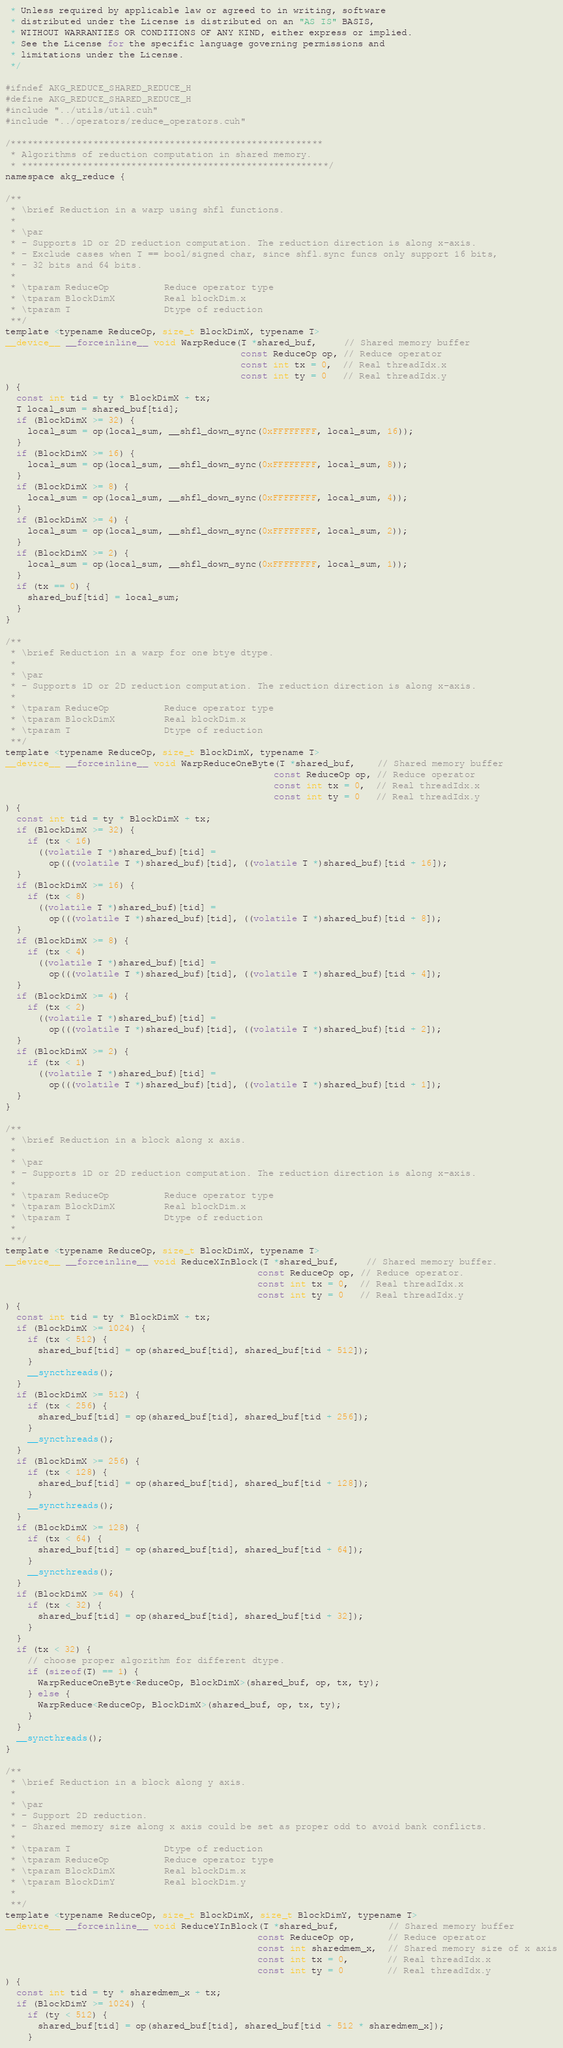Convert code to text. <code><loc_0><loc_0><loc_500><loc_500><_Cuda_> * Unless required by applicable law or agreed to in writing, software
 * distributed under the License is distributed on an "AS IS" BASIS,
 * WITHOUT WARRANTIES OR CONDITIONS OF ANY KIND, either express or implied.
 * See the License for the specific language governing permissions and
 * limitations under the License.
 */

#ifndef AKG_REDUCE_SHARED_REDUCE_H
#define AKG_REDUCE_SHARED_REDUCE_H
#include "../utils/util.cuh"
#include "../operators/reduce_operators.cuh"

/*********************************************************
 * Algorithms of reduction computation in shared memory.
 * ********************************************************/
namespace akg_reduce {

/**
 * \brief Reduction in a warp using shfl functions.
 *
 * \par
 * - Supports 1D or 2D reduction computation. The reduction direction is along x-axis.
 * - Exclude cases when T == bool/signed char, since shfl.sync funcs only support 16 bits,
 * - 32 bits and 64 bits.
 *
 * \tparam ReduceOp          Reduce operator type
 * \tparam BlockDimX         Real blockDim.x
 * \tparam T                 Dtype of reduction
 **/
template <typename ReduceOp, size_t BlockDimX, typename T>
__device__ __forceinline__ void WarpReduce(T *shared_buf,     // Shared memory buffer
                                           const ReduceOp op, // Reduce operator
                                           const int tx = 0,  // Real threadIdx.x
                                           const int ty = 0   // Real threadIdx.y
) {
  const int tid = ty * BlockDimX + tx;
  T local_sum = shared_buf[tid];
  if (BlockDimX >= 32) {
    local_sum = op(local_sum, __shfl_down_sync(0xFFFFFFFF, local_sum, 16));
  }
  if (BlockDimX >= 16) {
    local_sum = op(local_sum, __shfl_down_sync(0xFFFFFFFF, local_sum, 8));
  }
  if (BlockDimX >= 8) {
    local_sum = op(local_sum, __shfl_down_sync(0xFFFFFFFF, local_sum, 4));
  }
  if (BlockDimX >= 4) {
    local_sum = op(local_sum, __shfl_down_sync(0xFFFFFFFF, local_sum, 2));
  }
  if (BlockDimX >= 2) {
    local_sum = op(local_sum, __shfl_down_sync(0xFFFFFFFF, local_sum, 1));
  }
  if (tx == 0) {
    shared_buf[tid] = local_sum;
  }
}

/**
 * \brief Reduction in a warp for one btye dtype.
 *
 * \par
 * - Supports 1D or 2D reduction computation. The reduction direction is along x-axis.
 *
 * \tparam ReduceOp          Reduce operator type
 * \tparam BlockDimX         Real blockDim.x
 * \tparam T                 Dtype of reduction
 **/
template <typename ReduceOp, size_t BlockDimX, typename T>
__device__ __forceinline__ void WarpReduceOneByte(T *shared_buf,    // Shared memory buffer
                                                 const ReduceOp op, // Reduce operator
                                                 const int tx = 0,  // Real threadIdx.x
                                                 const int ty = 0   // Real threadIdx.y
) {
  const int tid = ty * BlockDimX + tx;
  if (BlockDimX >= 32) {
    if (tx < 16)
      ((volatile T *)shared_buf)[tid] =
        op(((volatile T *)shared_buf)[tid], ((volatile T *)shared_buf)[tid + 16]);
  }
  if (BlockDimX >= 16) {
    if (tx < 8)
      ((volatile T *)shared_buf)[tid] =
        op(((volatile T *)shared_buf)[tid], ((volatile T *)shared_buf)[tid + 8]);
  }
  if (BlockDimX >= 8) {
    if (tx < 4)
      ((volatile T *)shared_buf)[tid] =
        op(((volatile T *)shared_buf)[tid], ((volatile T *)shared_buf)[tid + 4]);
  }
  if (BlockDimX >= 4) {
    if (tx < 2)
      ((volatile T *)shared_buf)[tid] =
        op(((volatile T *)shared_buf)[tid], ((volatile T *)shared_buf)[tid + 2]);
  }
  if (BlockDimX >= 2) {
    if (tx < 1)
      ((volatile T *)shared_buf)[tid] =
        op(((volatile T *)shared_buf)[tid], ((volatile T *)shared_buf)[tid + 1]);
  }
}

/**
 * \brief Reduction in a block along x axis.
 *
 * \par
 * - Supports 1D or 2D reduction computation. The reduction direction is along x-axis.
 *
 * \tparam ReduceOp          Reduce operator type
 * \tparam BlockDimX         Real blockDim.x
 * \tparam T                 Dtype of reduction
 *
 **/
template <typename ReduceOp, size_t BlockDimX, typename T>
__device__ __forceinline__ void ReduceXInBlock(T *shared_buf,     // Shared memory buffer.
                                              const ReduceOp op, // Reduce operator.
                                              const int tx = 0,  // Real threadIdx.x
                                              const int ty = 0   // Real threadIdx.y
) {
  const int tid = ty * BlockDimX + tx;
  if (BlockDimX >= 1024) {
    if (tx < 512) {
      shared_buf[tid] = op(shared_buf[tid], shared_buf[tid + 512]);
    }
    __syncthreads();
  }
  if (BlockDimX >= 512) {
    if (tx < 256) {
      shared_buf[tid] = op(shared_buf[tid], shared_buf[tid + 256]);
    }
    __syncthreads();
  }
  if (BlockDimX >= 256) {
    if (tx < 128) {
      shared_buf[tid] = op(shared_buf[tid], shared_buf[tid + 128]);
    }
    __syncthreads();
  }
  if (BlockDimX >= 128) {
    if (tx < 64) {
      shared_buf[tid] = op(shared_buf[tid], shared_buf[tid + 64]);
    }
    __syncthreads();
  }
  if (BlockDimX >= 64) {
    if (tx < 32) {
      shared_buf[tid] = op(shared_buf[tid], shared_buf[tid + 32]);
    }
  }
  if (tx < 32) {
    // choose proper algorithm for different dtype.
    if (sizeof(T) == 1) {
      WarpReduceOneByte<ReduceOp, BlockDimX>(shared_buf, op, tx, ty);
    } else {
      WarpReduce<ReduceOp, BlockDimX>(shared_buf, op, tx, ty);
    }
  }
  __syncthreads();
}

/**
 * \brief Reduction in a block along y axis.
 *
 * \par
 * - Support 2D reduction.
 * - Shared memory size along x axis could be set as proper odd to avoid bank conflicts.
 *
 * \tparam T                 Dtype of reduction
 * \tparam ReduceOp          Reduce operator type
 * \tparam BlockDimX         Real blockDim.x
 * \tparam BlockDimY         Real blockDim.y
 *
 **/
template <typename ReduceOp, size_t BlockDimX, size_t BlockDimY, typename T>
__device__ __forceinline__ void ReduceYInBlock(T *shared_buf,         // Shared memory buffer
                                              const ReduceOp op,      // Reduce operator
                                              const int sharedmem_x,  // Shared memory size of x axis
                                              const int tx = 0,       // Real threadIdx.x
                                              const int ty = 0        // Real threadIdx.y
) {
  const int tid = ty * sharedmem_x + tx;
  if (BlockDimY >= 1024) {
    if (ty < 512) {
      shared_buf[tid] = op(shared_buf[tid], shared_buf[tid + 512 * sharedmem_x]);
    }</code> 